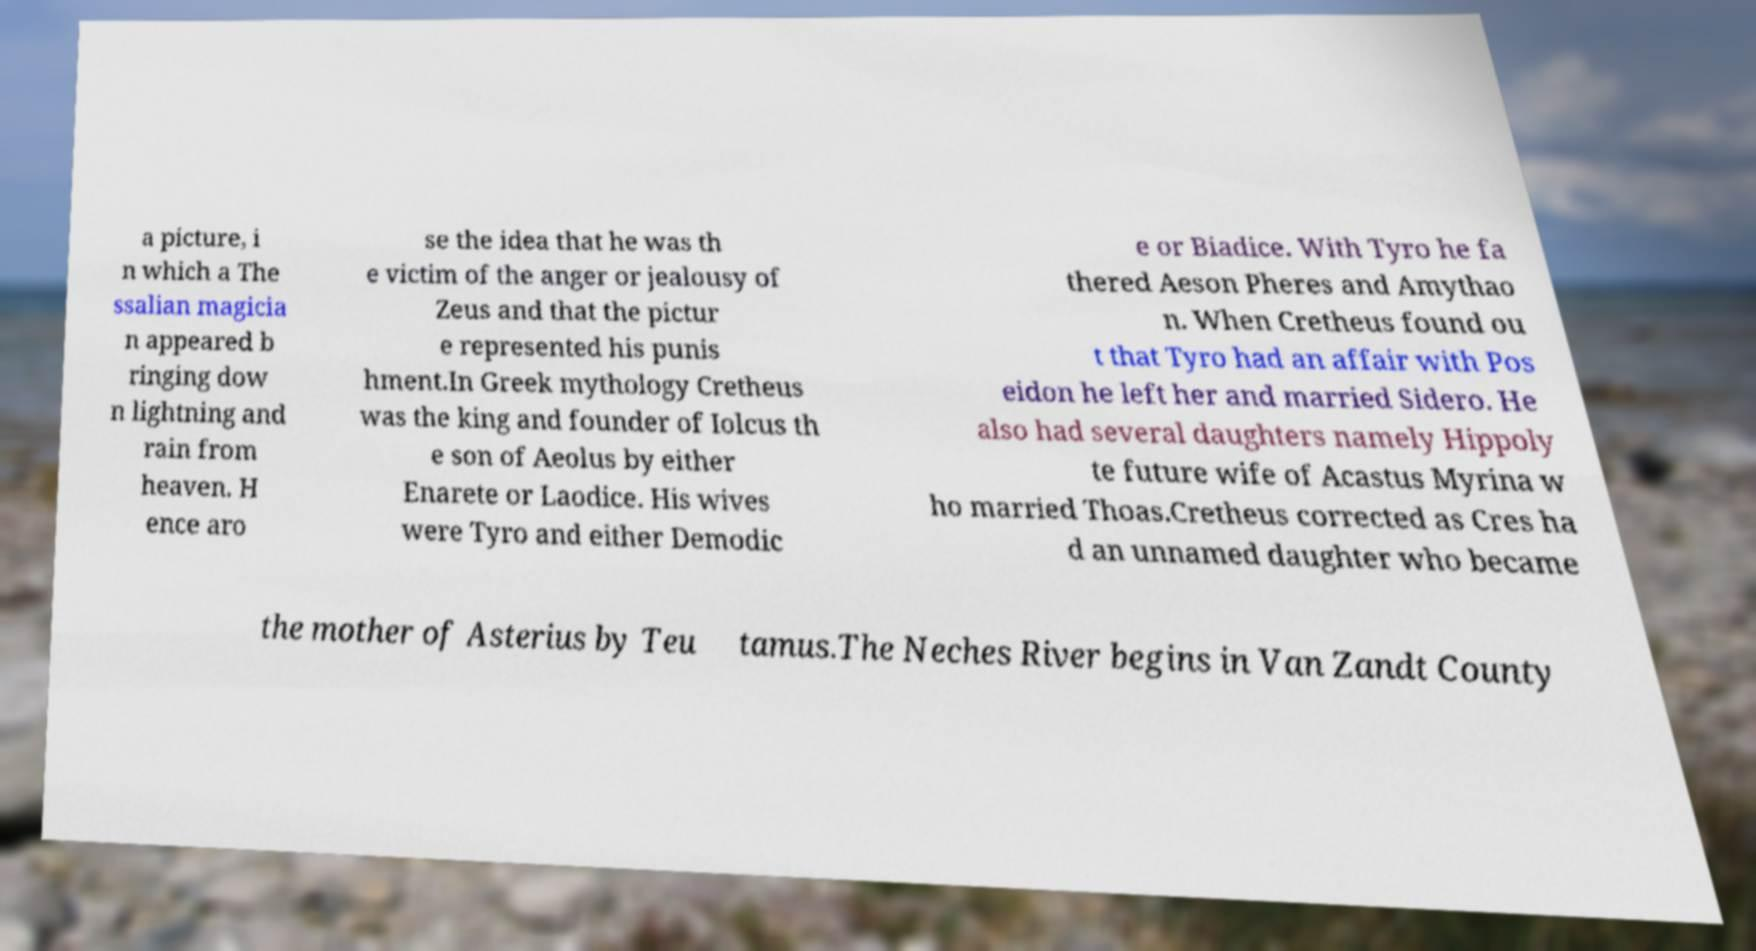Can you accurately transcribe the text from the provided image for me? a picture, i n which a The ssalian magicia n appeared b ringing dow n lightning and rain from heaven. H ence aro se the idea that he was th e victim of the anger or jealousy of Zeus and that the pictur e represented his punis hment.In Greek mythology Cretheus was the king and founder of Iolcus th e son of Aeolus by either Enarete or Laodice. His wives were Tyro and either Demodic e or Biadice. With Tyro he fa thered Aeson Pheres and Amythao n. When Cretheus found ou t that Tyro had an affair with Pos eidon he left her and married Sidero. He also had several daughters namely Hippoly te future wife of Acastus Myrina w ho married Thoas.Cretheus corrected as Cres ha d an unnamed daughter who became the mother of Asterius by Teu tamus.The Neches River begins in Van Zandt County 